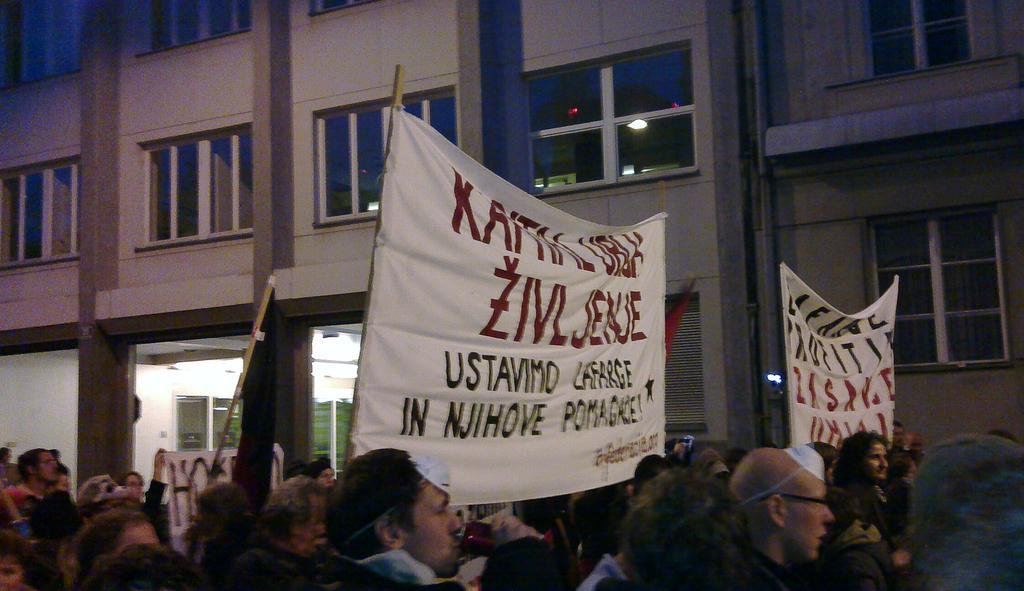Describe this image in one or two sentences. In this image at the bottom there are a group of people who are holding some placards and some sticks. In the background there are some buildings and glass windows. 